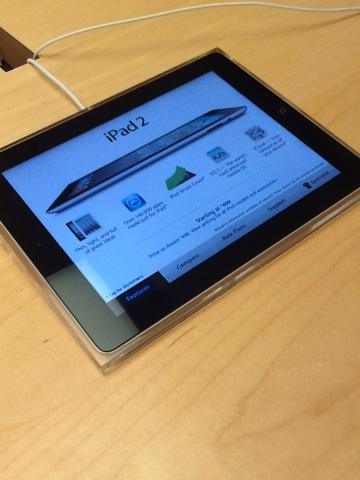What is this? This is an iPad 2, a tablet computer designed by Apple Inc. Released in March 2011, the iPad 2 features a 9.7-inch display, dual-core A5 chip, and is compatible with various iOS apps for productivity, entertainment, and communication. 